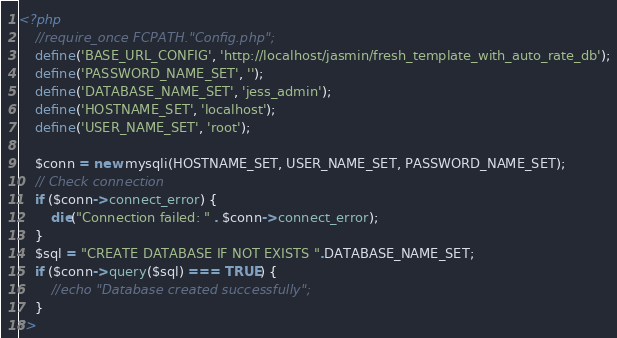Convert code to text. <code><loc_0><loc_0><loc_500><loc_500><_PHP_><?php
    //require_once FCPATH."Config.php";
    define('BASE_URL_CONFIG', 'http://localhost/jasmin/fresh_template_with_auto_rate_db');
    define('PASSWORD_NAME_SET', '');
    define('DATABASE_NAME_SET', 'jess_admin');
    define('HOSTNAME_SET', 'localhost');
    define('USER_NAME_SET', 'root');

    $conn = new mysqli(HOSTNAME_SET, USER_NAME_SET, PASSWORD_NAME_SET);
	// Check connection
	if ($conn->connect_error) {
	    die("Connection failed: " . $conn->connect_error);
	} 
	$sql = "CREATE DATABASE IF NOT EXISTS ".DATABASE_NAME_SET;
	if ($conn->query($sql) === TRUE) {
	    //echo "Database created successfully";
	}
?></code> 